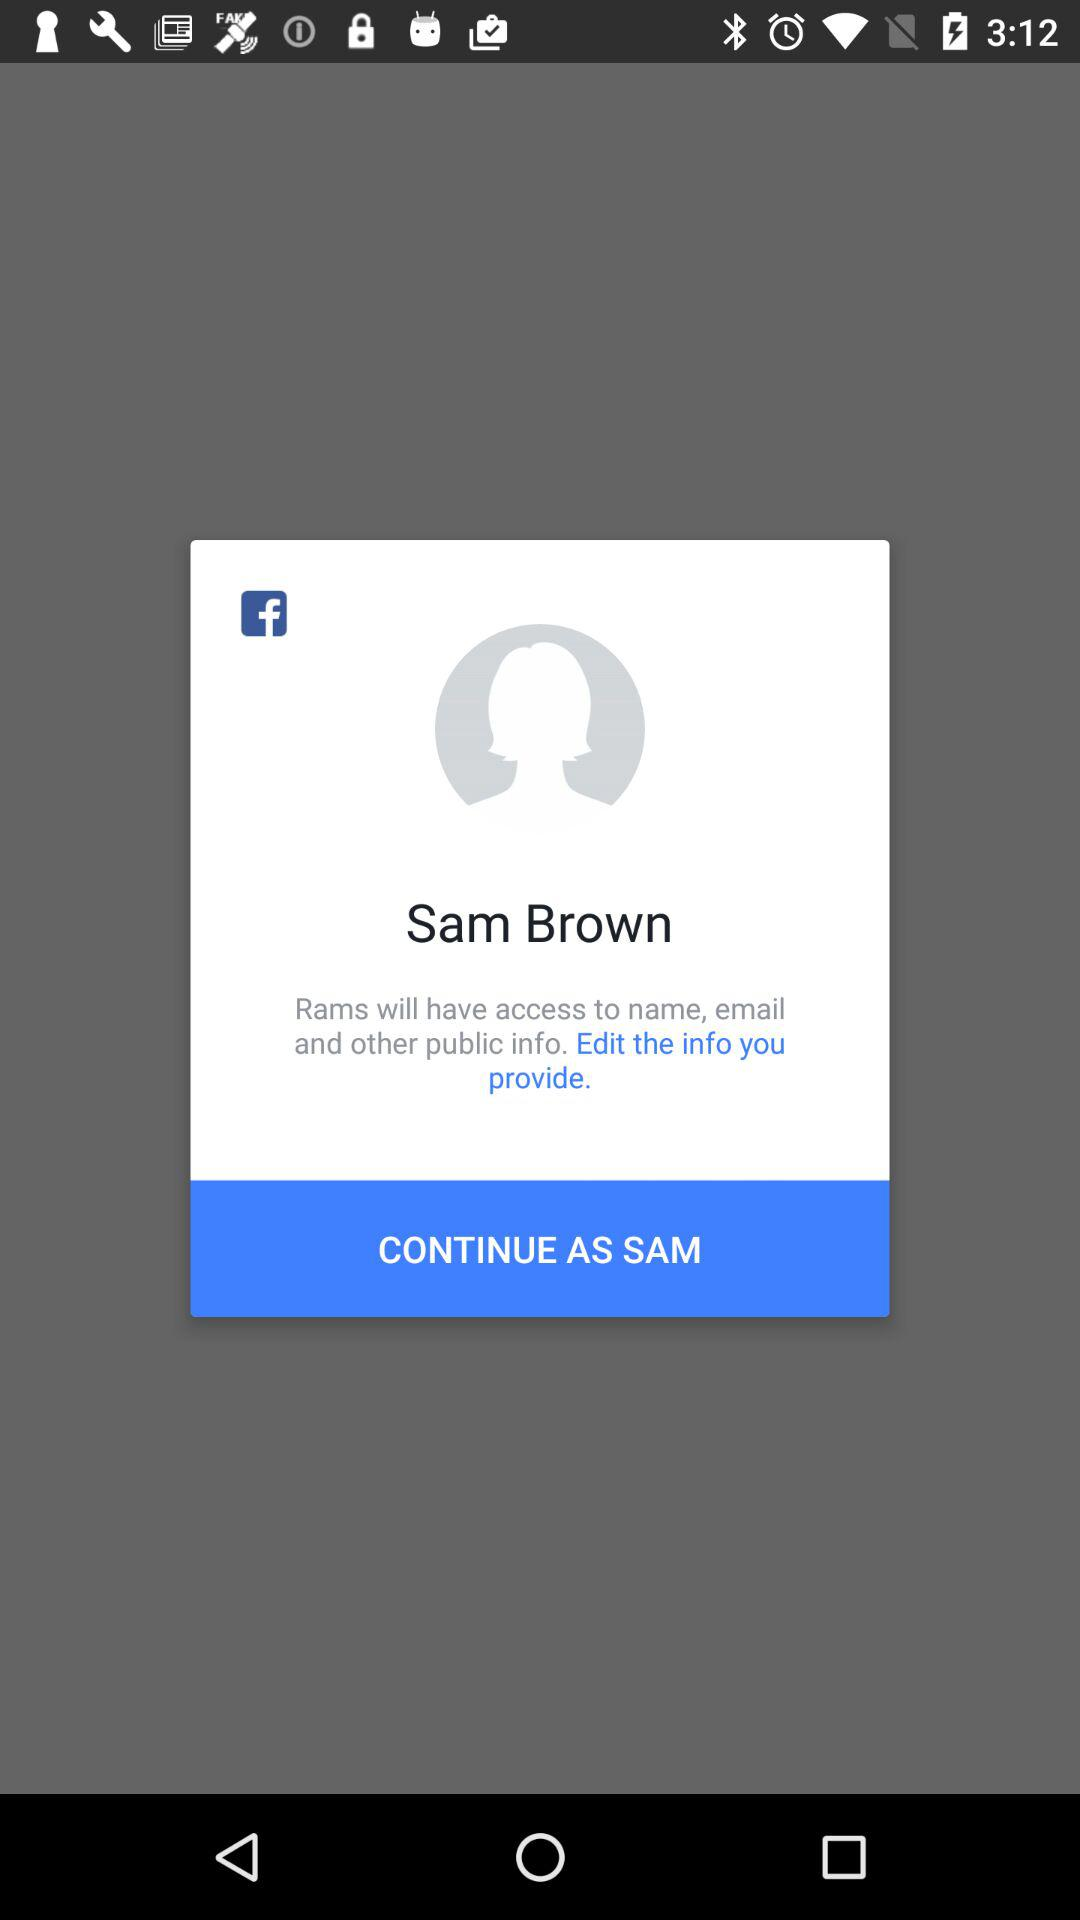What is the user name? The user name is Sam Brown. 